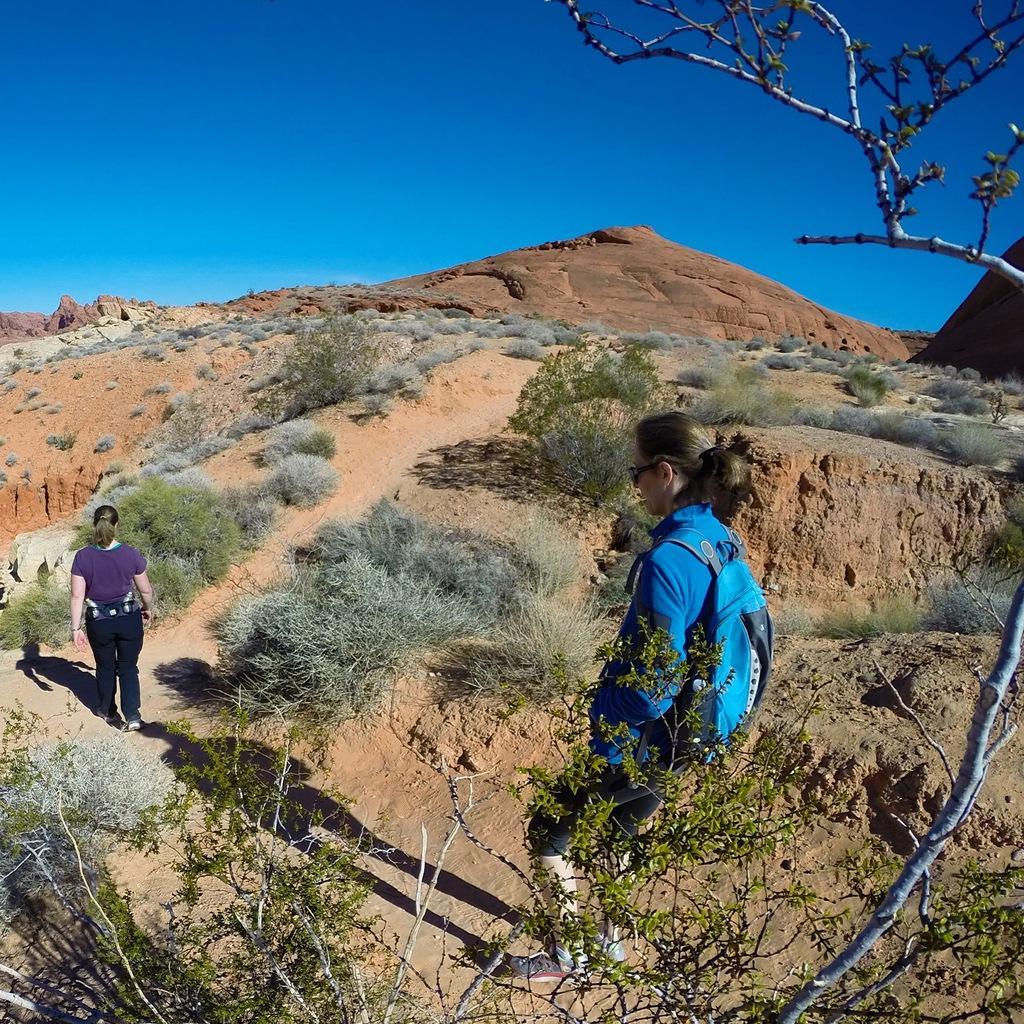How would you summarize this image in a sentence or two? In this image we can see women, grass, plants, trees, hill, rocks and sky. 